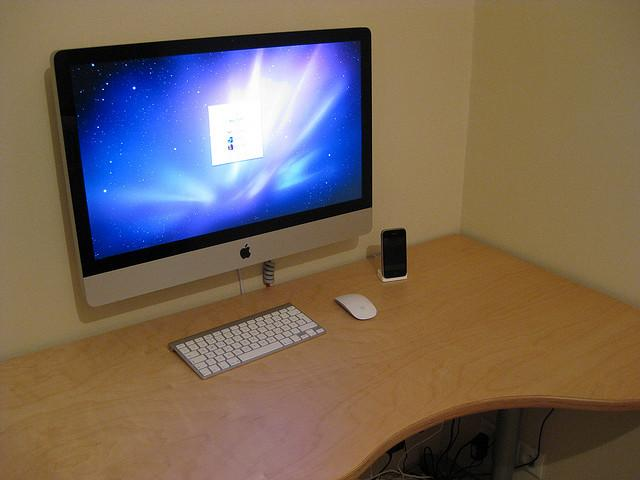What is on the desk?

Choices:
A) laptop
B) stuffed doll
C) textbook
D) candy dish laptop 